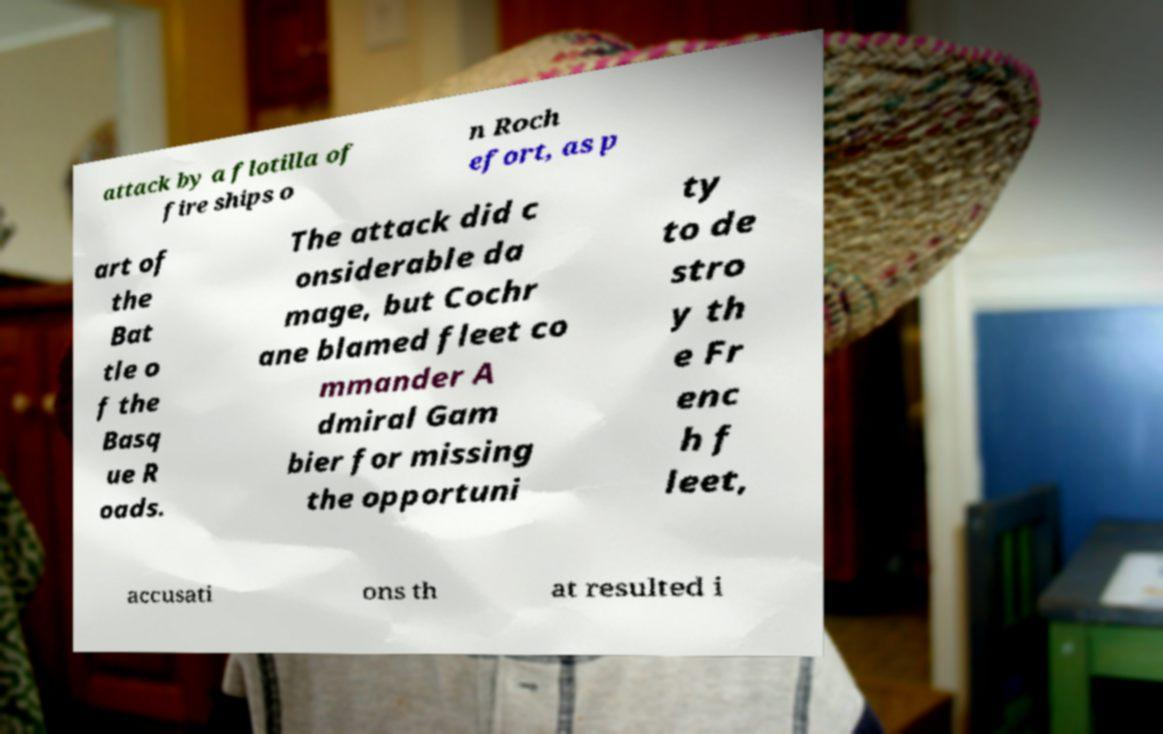Can you read and provide the text displayed in the image?This photo seems to have some interesting text. Can you extract and type it out for me? attack by a flotilla of fire ships o n Roch efort, as p art of the Bat tle o f the Basq ue R oads. The attack did c onsiderable da mage, but Cochr ane blamed fleet co mmander A dmiral Gam bier for missing the opportuni ty to de stro y th e Fr enc h f leet, accusati ons th at resulted i 